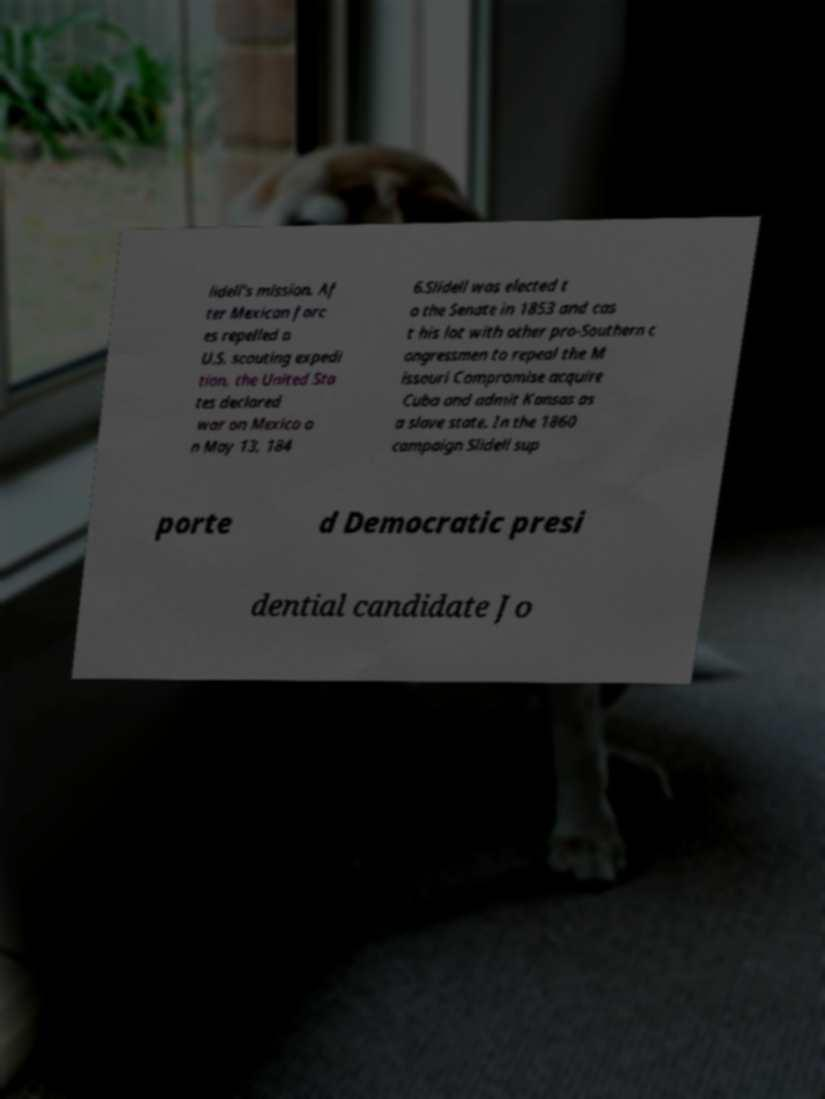Could you assist in decoding the text presented in this image and type it out clearly? lidell's mission. Af ter Mexican forc es repelled a U.S. scouting expedi tion, the United Sta tes declared war on Mexico o n May 13, 184 6.Slidell was elected t o the Senate in 1853 and cas t his lot with other pro-Southern c ongressmen to repeal the M issouri Compromise acquire Cuba and admit Kansas as a slave state. In the 1860 campaign Slidell sup porte d Democratic presi dential candidate Jo 